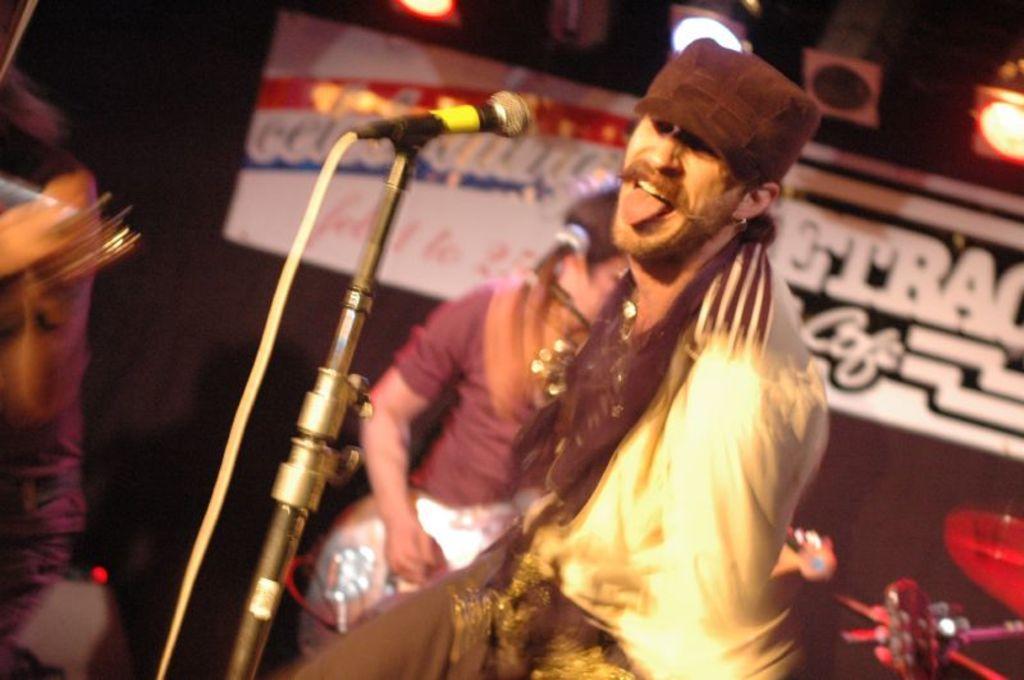Could you give a brief overview of what you see in this image? In this image, we can see a man standing, he is wearing a hat, we can see a microphone, in the background, we can see a person standing and holding a musical instrument, we can see a poster and we can see some lights. 